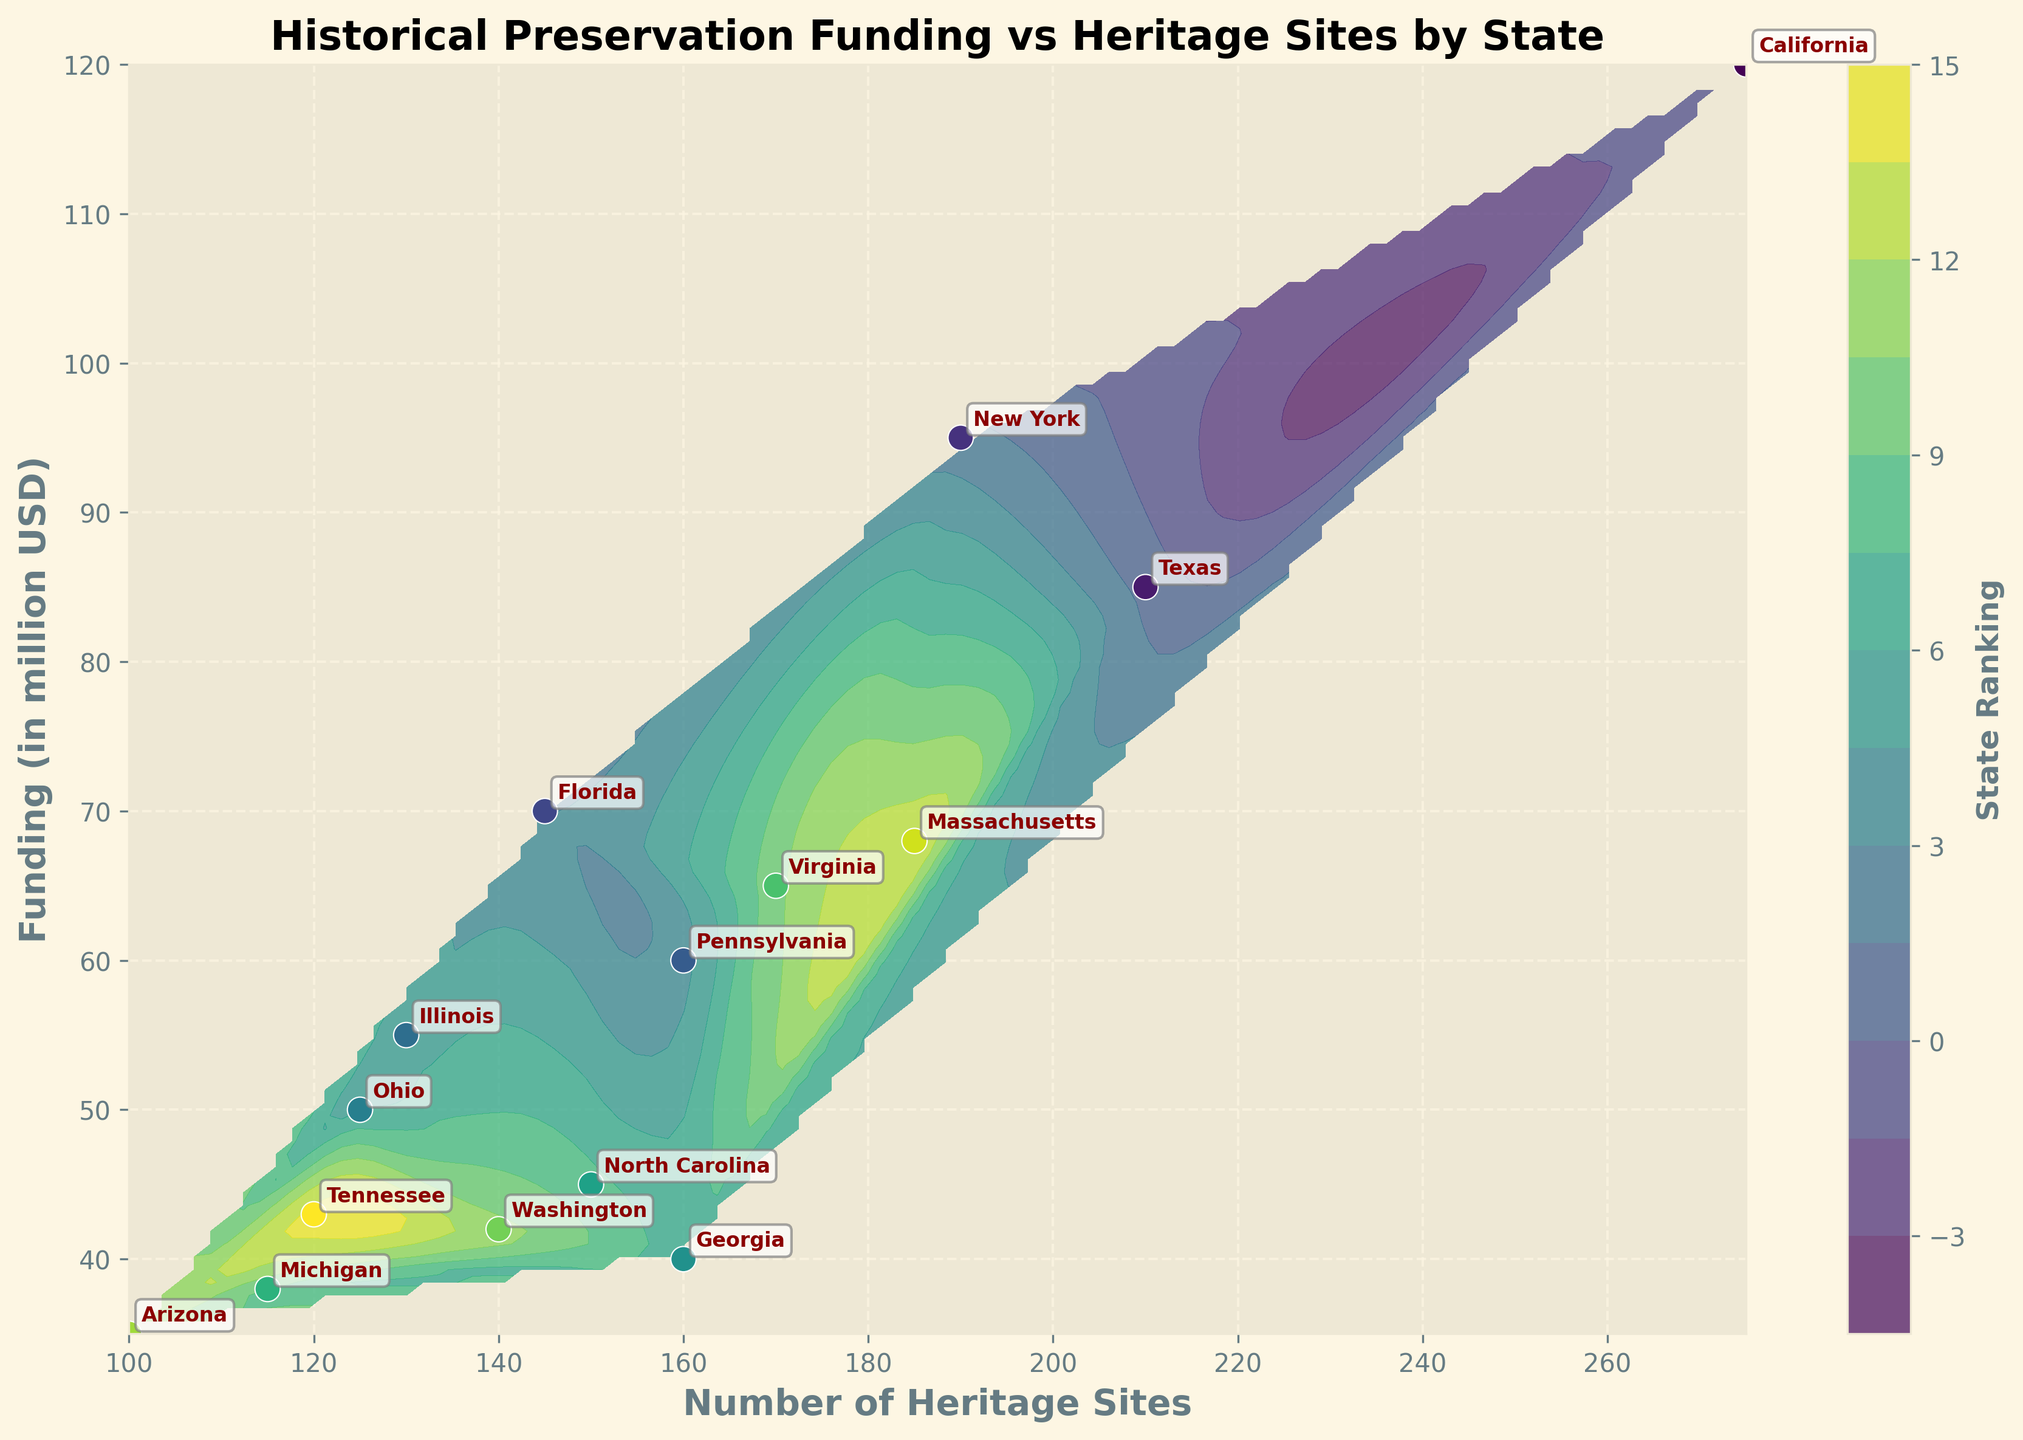What is the title of the plot? The title of the plot is displayed at the top and summarizes the content of the visual, which is "Historical Preservation Funding vs Heritage Sites by State." This helps to quickly understand what the plot is about.
Answer: Historical Preservation Funding vs Heritage Sites by State How does the number of heritage sites correlate with the funding amount? The contour lines on the plot and the arrangement of the scatter points show the distribution and correlation. Generally, you can observe if there is a pattern of increasing heritage sites with increasing funding, indicating a possible correlation.
Answer: Positive correlation Which state has the highest funding for historical preservation? The state with the highest funding will be located at the highest point on the y-axis. By looking at the data points, California is positioned the highest, indicating it has the most funding.
Answer: California Describe the color gradient used for the contour plot. The colors in the contour plot range from lighter to darker shades, with darker shades typically representing higher density or higher values in ranking according to the color bar.
Answer: Lighter to darker shades Which states have funding below 50 million USD? Referencing the points below 50 on the y-axis, the states that fall below this threshold are Ohio, Georgia, Michigan, Arizona, and Tennessee.
Answer: Ohio, Georgia, Michigan, Arizona, Tennessee What is the average funding for states with more than 150 heritage sites? Locate the states with more than 150 heritage sites (California, Texas, Georgia, Virginia, and New York) and then calculate the average of their funding: (120 + 85 + 40 + 65 + 95) / 5 = 81 million USD.
Answer: 81 million USD Between Illinois and Virginia, which state has more heritage sites and higher funding? Illinois and Virginia can be identified on the plot based on their locations: Illinois has 130 sites and 55 million USD, while Virginia has 170 sites and 65 million USD. Thus, Virginia exceeds Illinois in both metrics.
Answer: Virginia How is the state ranking indicated on the plot? The state ranking is indicated by the color gradient of the scatter points, which are colored according to their rank from the color bar, ascending from a certain hue to another.
Answer: By color gradient Which state is denoted at the point with roughly 120 heritage sites and 50 million USD funding? Looking closely at the approximate coordinates near 120 on the x-axis and 50 on the y-axis, the annotation denotes that Ohio is the corresponding state.
Answer: Ohio How many states have more than 150 heritage sites? To determine this, count the states that are positioned at points greater than 150 on the x-axis. The states include California, Texas, Georgia, and Virginia, making it four states.
Answer: Four states 